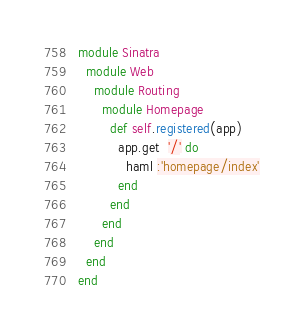<code> <loc_0><loc_0><loc_500><loc_500><_Ruby_>module Sinatra
  module Web
    module Routing
      module Homepage
        def self.registered(app)
          app.get  '/' do
            haml :'homepage/index'
          end
        end
      end
    end
  end
end
</code> 